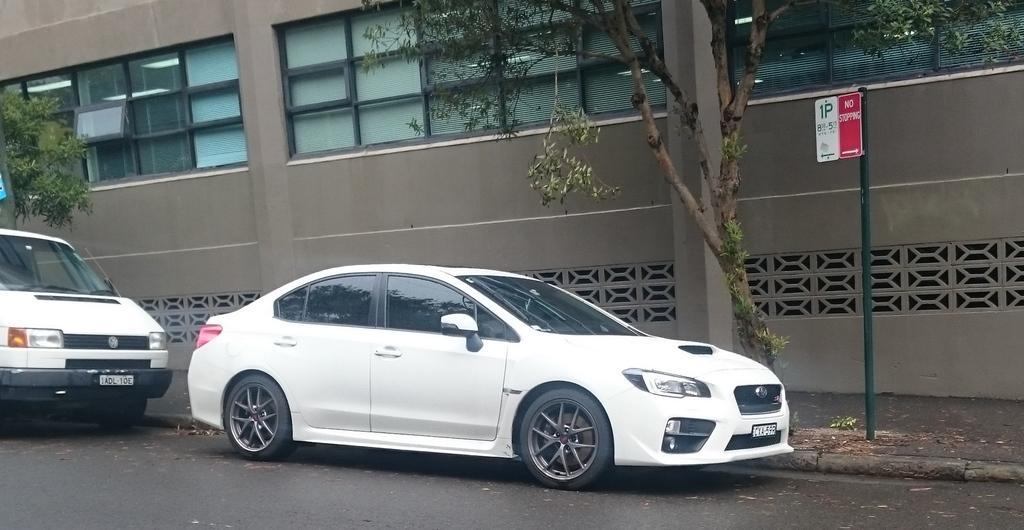In one or two sentences, can you explain what this image depicts? In this picture we can see couple of cars on the road, beside to the cars we can find few trees, sign board, metal rod and a building. 